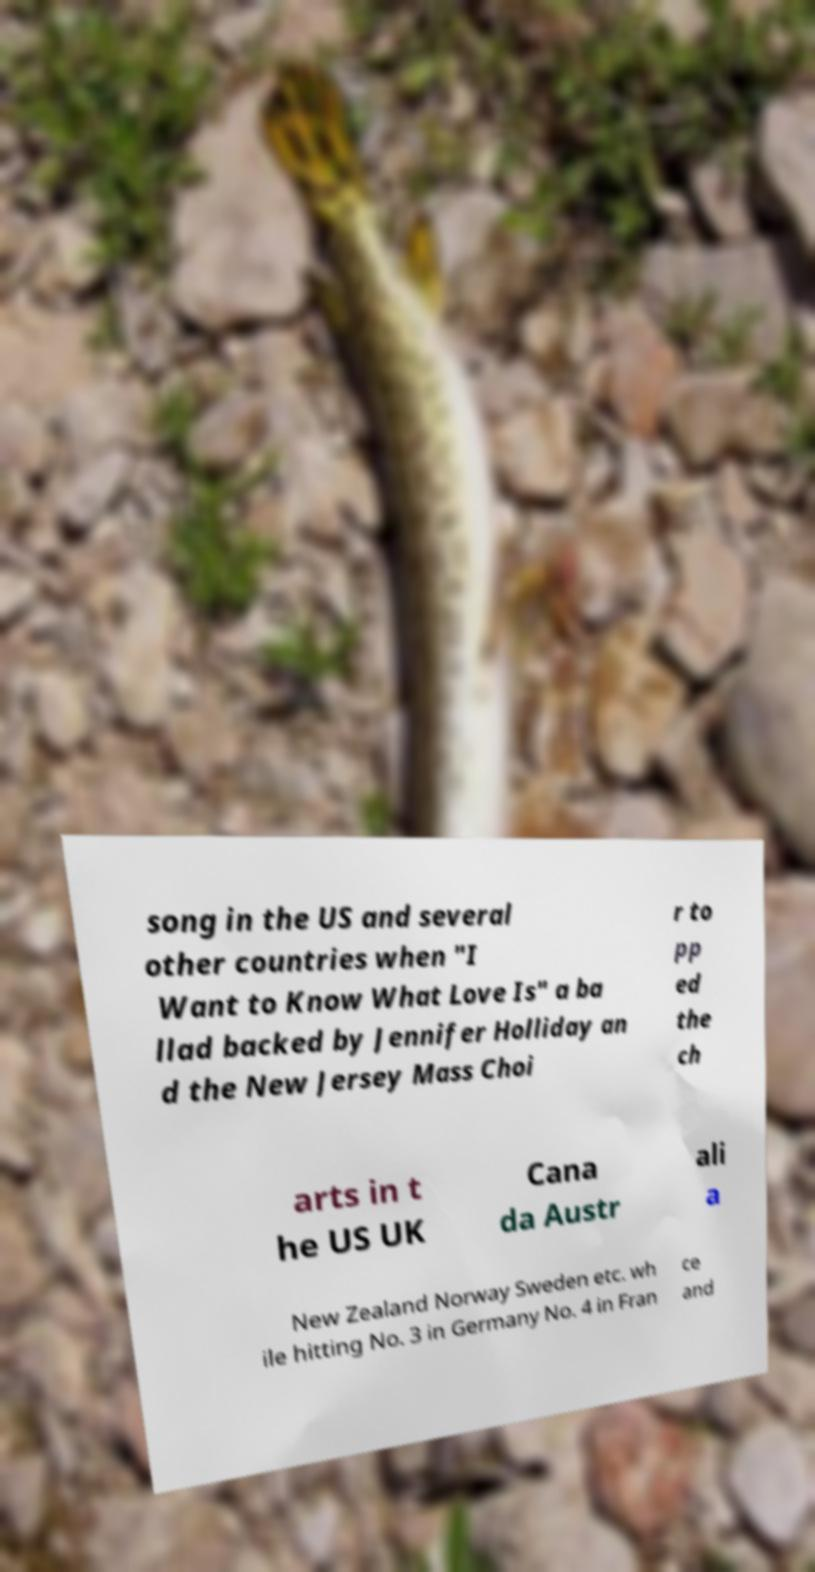Can you accurately transcribe the text from the provided image for me? song in the US and several other countries when "I Want to Know What Love Is" a ba llad backed by Jennifer Holliday an d the New Jersey Mass Choi r to pp ed the ch arts in t he US UK Cana da Austr ali a New Zealand Norway Sweden etc. wh ile hitting No. 3 in Germany No. 4 in Fran ce and 